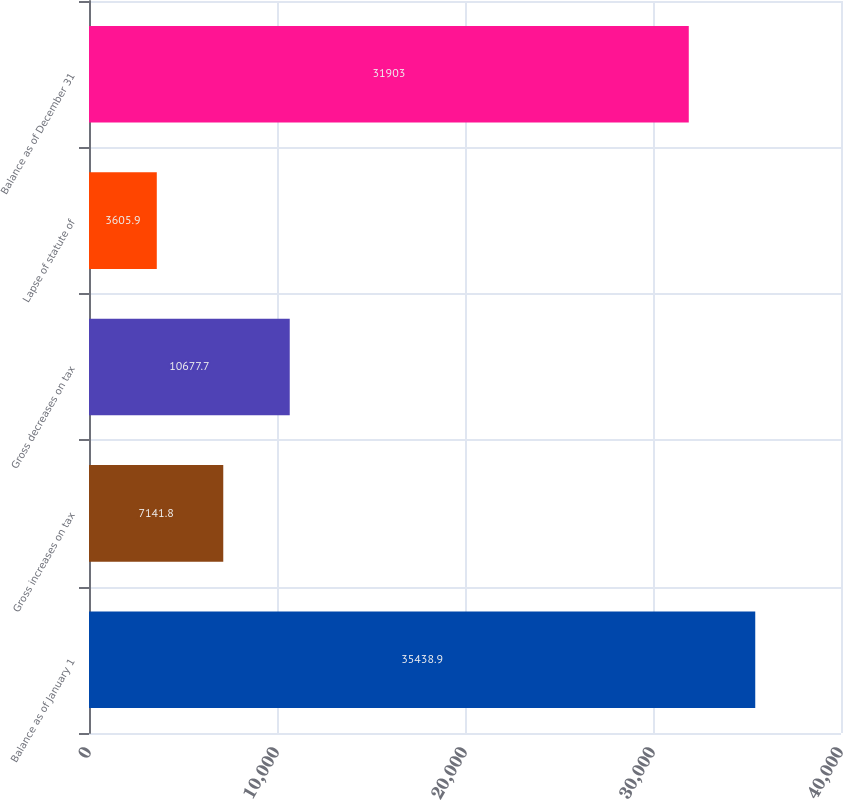<chart> <loc_0><loc_0><loc_500><loc_500><bar_chart><fcel>Balance as of January 1<fcel>Gross increases on tax<fcel>Gross decreases on tax<fcel>Lapse of statute of<fcel>Balance as of December 31<nl><fcel>35438.9<fcel>7141.8<fcel>10677.7<fcel>3605.9<fcel>31903<nl></chart> 